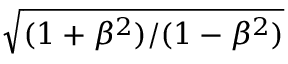Convert formula to latex. <formula><loc_0><loc_0><loc_500><loc_500>\sqrt { ( 1 + \beta ^ { 2 } ) / ( 1 - \beta ^ { 2 } ) }</formula> 